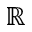<formula> <loc_0><loc_0><loc_500><loc_500>\mathbb { R }</formula> 